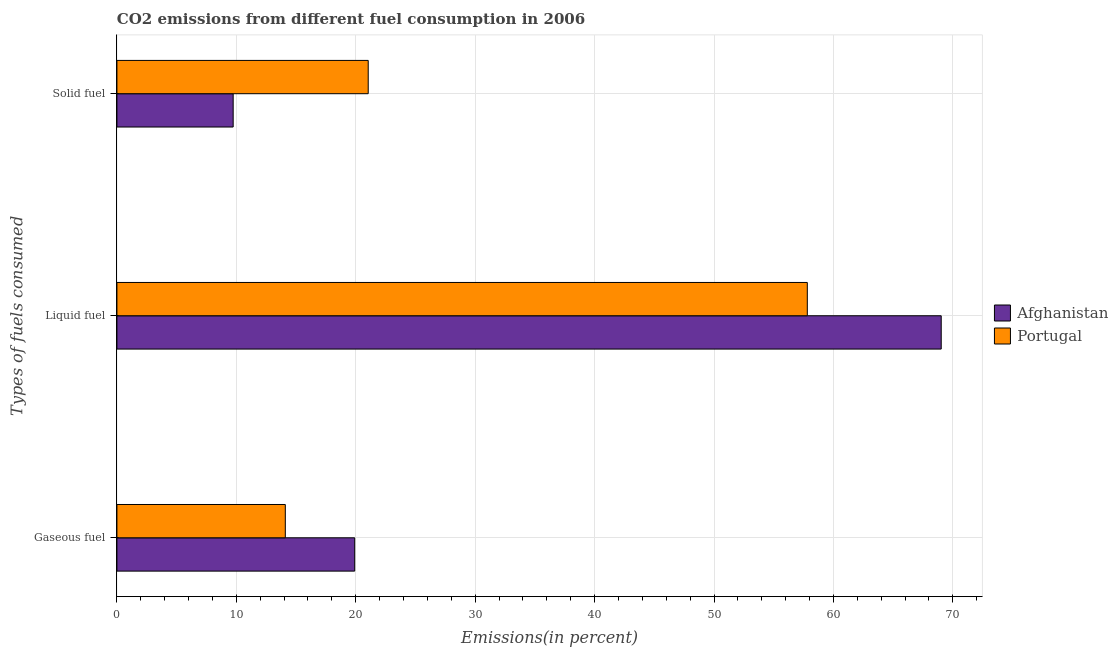How many groups of bars are there?
Provide a short and direct response. 3. How many bars are there on the 2nd tick from the top?
Give a very brief answer. 2. How many bars are there on the 1st tick from the bottom?
Give a very brief answer. 2. What is the label of the 3rd group of bars from the top?
Give a very brief answer. Gaseous fuel. What is the percentage of liquid fuel emission in Afghanistan?
Ensure brevity in your answer.  69.03. Across all countries, what is the maximum percentage of gaseous fuel emission?
Provide a succinct answer. 19.91. Across all countries, what is the minimum percentage of solid fuel emission?
Give a very brief answer. 9.73. In which country was the percentage of solid fuel emission maximum?
Your response must be concise. Portugal. In which country was the percentage of solid fuel emission minimum?
Your response must be concise. Afghanistan. What is the total percentage of gaseous fuel emission in the graph?
Offer a terse response. 34.01. What is the difference between the percentage of gaseous fuel emission in Afghanistan and that in Portugal?
Give a very brief answer. 5.81. What is the difference between the percentage of solid fuel emission in Portugal and the percentage of gaseous fuel emission in Afghanistan?
Provide a succinct answer. 1.13. What is the average percentage of solid fuel emission per country?
Offer a very short reply. 15.39. What is the difference between the percentage of liquid fuel emission and percentage of solid fuel emission in Afghanistan?
Ensure brevity in your answer.  59.29. What is the ratio of the percentage of gaseous fuel emission in Afghanistan to that in Portugal?
Provide a short and direct response. 1.41. Is the percentage of liquid fuel emission in Portugal less than that in Afghanistan?
Provide a short and direct response. Yes. Is the difference between the percentage of solid fuel emission in Portugal and Afghanistan greater than the difference between the percentage of gaseous fuel emission in Portugal and Afghanistan?
Keep it short and to the point. Yes. What is the difference between the highest and the second highest percentage of liquid fuel emission?
Offer a terse response. 11.21. What is the difference between the highest and the lowest percentage of solid fuel emission?
Offer a terse response. 11.31. Is the sum of the percentage of gaseous fuel emission in Afghanistan and Portugal greater than the maximum percentage of liquid fuel emission across all countries?
Your answer should be compact. No. What does the 2nd bar from the top in Liquid fuel represents?
Your answer should be compact. Afghanistan. What does the 2nd bar from the bottom in Liquid fuel represents?
Your answer should be very brief. Portugal. How many legend labels are there?
Make the answer very short. 2. How are the legend labels stacked?
Keep it short and to the point. Vertical. What is the title of the graph?
Provide a succinct answer. CO2 emissions from different fuel consumption in 2006. What is the label or title of the X-axis?
Keep it short and to the point. Emissions(in percent). What is the label or title of the Y-axis?
Offer a very short reply. Types of fuels consumed. What is the Emissions(in percent) in Afghanistan in Gaseous fuel?
Offer a terse response. 19.91. What is the Emissions(in percent) of Portugal in Gaseous fuel?
Make the answer very short. 14.1. What is the Emissions(in percent) of Afghanistan in Liquid fuel?
Your answer should be compact. 69.03. What is the Emissions(in percent) in Portugal in Liquid fuel?
Offer a very short reply. 57.81. What is the Emissions(in percent) of Afghanistan in Solid fuel?
Offer a terse response. 9.73. What is the Emissions(in percent) of Portugal in Solid fuel?
Provide a short and direct response. 21.04. Across all Types of fuels consumed, what is the maximum Emissions(in percent) of Afghanistan?
Provide a succinct answer. 69.03. Across all Types of fuels consumed, what is the maximum Emissions(in percent) of Portugal?
Provide a short and direct response. 57.81. Across all Types of fuels consumed, what is the minimum Emissions(in percent) of Afghanistan?
Give a very brief answer. 9.73. Across all Types of fuels consumed, what is the minimum Emissions(in percent) in Portugal?
Provide a succinct answer. 14.1. What is the total Emissions(in percent) of Afghanistan in the graph?
Provide a succinct answer. 98.67. What is the total Emissions(in percent) in Portugal in the graph?
Your response must be concise. 92.96. What is the difference between the Emissions(in percent) of Afghanistan in Gaseous fuel and that in Liquid fuel?
Offer a terse response. -49.12. What is the difference between the Emissions(in percent) of Portugal in Gaseous fuel and that in Liquid fuel?
Provide a succinct answer. -43.71. What is the difference between the Emissions(in percent) in Afghanistan in Gaseous fuel and that in Solid fuel?
Provide a short and direct response. 10.18. What is the difference between the Emissions(in percent) in Portugal in Gaseous fuel and that in Solid fuel?
Make the answer very short. -6.94. What is the difference between the Emissions(in percent) of Afghanistan in Liquid fuel and that in Solid fuel?
Your answer should be compact. 59.29. What is the difference between the Emissions(in percent) in Portugal in Liquid fuel and that in Solid fuel?
Your response must be concise. 36.77. What is the difference between the Emissions(in percent) of Afghanistan in Gaseous fuel and the Emissions(in percent) of Portugal in Liquid fuel?
Provide a short and direct response. -37.9. What is the difference between the Emissions(in percent) in Afghanistan in Gaseous fuel and the Emissions(in percent) in Portugal in Solid fuel?
Give a very brief answer. -1.13. What is the difference between the Emissions(in percent) of Afghanistan in Liquid fuel and the Emissions(in percent) of Portugal in Solid fuel?
Offer a very short reply. 47.98. What is the average Emissions(in percent) of Afghanistan per Types of fuels consumed?
Keep it short and to the point. 32.89. What is the average Emissions(in percent) in Portugal per Types of fuels consumed?
Give a very brief answer. 30.99. What is the difference between the Emissions(in percent) in Afghanistan and Emissions(in percent) in Portugal in Gaseous fuel?
Make the answer very short. 5.81. What is the difference between the Emissions(in percent) of Afghanistan and Emissions(in percent) of Portugal in Liquid fuel?
Make the answer very short. 11.21. What is the difference between the Emissions(in percent) in Afghanistan and Emissions(in percent) in Portugal in Solid fuel?
Your response must be concise. -11.31. What is the ratio of the Emissions(in percent) of Afghanistan in Gaseous fuel to that in Liquid fuel?
Make the answer very short. 0.29. What is the ratio of the Emissions(in percent) of Portugal in Gaseous fuel to that in Liquid fuel?
Your answer should be compact. 0.24. What is the ratio of the Emissions(in percent) of Afghanistan in Gaseous fuel to that in Solid fuel?
Offer a terse response. 2.05. What is the ratio of the Emissions(in percent) of Portugal in Gaseous fuel to that in Solid fuel?
Offer a very short reply. 0.67. What is the ratio of the Emissions(in percent) in Afghanistan in Liquid fuel to that in Solid fuel?
Your answer should be compact. 7.09. What is the ratio of the Emissions(in percent) of Portugal in Liquid fuel to that in Solid fuel?
Give a very brief answer. 2.75. What is the difference between the highest and the second highest Emissions(in percent) in Afghanistan?
Offer a terse response. 49.12. What is the difference between the highest and the second highest Emissions(in percent) in Portugal?
Make the answer very short. 36.77. What is the difference between the highest and the lowest Emissions(in percent) in Afghanistan?
Offer a terse response. 59.29. What is the difference between the highest and the lowest Emissions(in percent) of Portugal?
Ensure brevity in your answer.  43.71. 